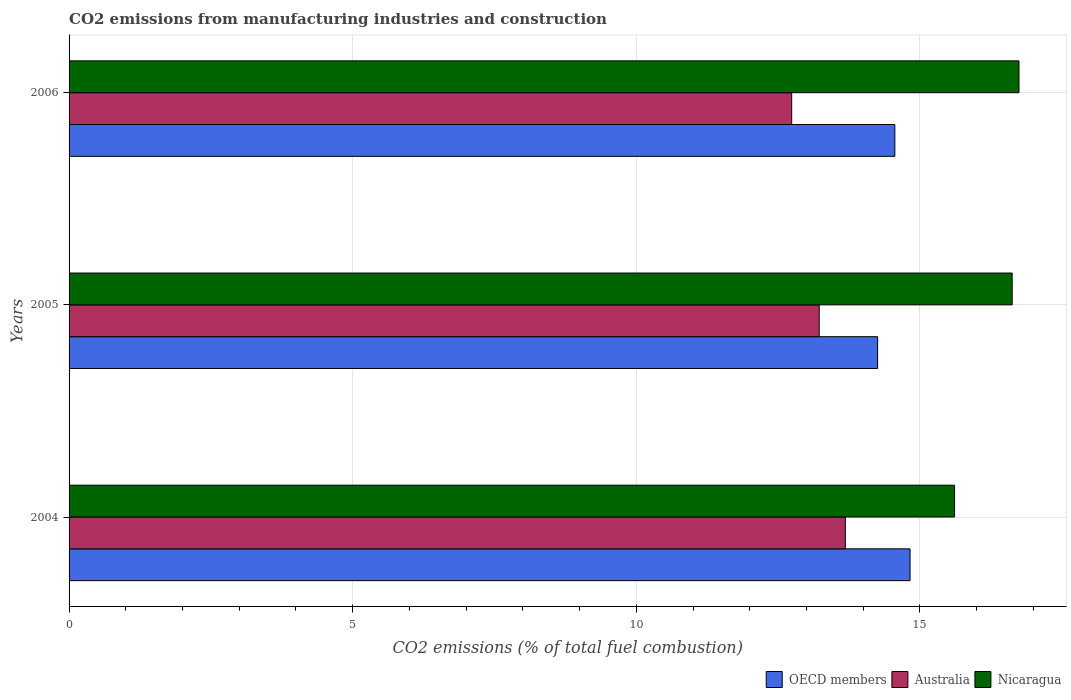How many different coloured bars are there?
Give a very brief answer. 3. Are the number of bars per tick equal to the number of legend labels?
Offer a very short reply. Yes. Are the number of bars on each tick of the Y-axis equal?
Give a very brief answer. Yes. How many bars are there on the 2nd tick from the top?
Your answer should be very brief. 3. How many bars are there on the 3rd tick from the bottom?
Your answer should be compact. 3. What is the label of the 1st group of bars from the top?
Your answer should be very brief. 2006. What is the amount of CO2 emitted in Australia in 2004?
Make the answer very short. 13.68. Across all years, what is the maximum amount of CO2 emitted in OECD members?
Give a very brief answer. 14.82. Across all years, what is the minimum amount of CO2 emitted in Nicaragua?
Keep it short and to the point. 15.61. In which year was the amount of CO2 emitted in Australia maximum?
Provide a short and direct response. 2004. What is the total amount of CO2 emitted in OECD members in the graph?
Ensure brevity in your answer.  43.63. What is the difference between the amount of CO2 emitted in OECD members in 2004 and that in 2006?
Give a very brief answer. 0.27. What is the difference between the amount of CO2 emitted in Australia in 2006 and the amount of CO2 emitted in Nicaragua in 2005?
Ensure brevity in your answer.  -3.89. What is the average amount of CO2 emitted in Nicaragua per year?
Give a very brief answer. 16.33. In the year 2004, what is the difference between the amount of CO2 emitted in Nicaragua and amount of CO2 emitted in OECD members?
Keep it short and to the point. 0.78. What is the ratio of the amount of CO2 emitted in Australia in 2005 to that in 2006?
Your response must be concise. 1.04. Is the amount of CO2 emitted in OECD members in 2004 less than that in 2005?
Your answer should be compact. No. Is the difference between the amount of CO2 emitted in Nicaragua in 2004 and 2006 greater than the difference between the amount of CO2 emitted in OECD members in 2004 and 2006?
Your response must be concise. No. What is the difference between the highest and the second highest amount of CO2 emitted in Nicaragua?
Ensure brevity in your answer.  0.12. What is the difference between the highest and the lowest amount of CO2 emitted in OECD members?
Provide a short and direct response. 0.57. In how many years, is the amount of CO2 emitted in OECD members greater than the average amount of CO2 emitted in OECD members taken over all years?
Your response must be concise. 2. What does the 2nd bar from the bottom in 2005 represents?
Your answer should be very brief. Australia. How many bars are there?
Your response must be concise. 9. Are all the bars in the graph horizontal?
Give a very brief answer. Yes. What is the difference between two consecutive major ticks on the X-axis?
Ensure brevity in your answer.  5. Are the values on the major ticks of X-axis written in scientific E-notation?
Offer a terse response. No. Does the graph contain any zero values?
Keep it short and to the point. No. Does the graph contain grids?
Your response must be concise. Yes. How are the legend labels stacked?
Your response must be concise. Horizontal. What is the title of the graph?
Offer a very short reply. CO2 emissions from manufacturing industries and construction. What is the label or title of the X-axis?
Your answer should be compact. CO2 emissions (% of total fuel combustion). What is the CO2 emissions (% of total fuel combustion) of OECD members in 2004?
Make the answer very short. 14.82. What is the CO2 emissions (% of total fuel combustion) in Australia in 2004?
Offer a terse response. 13.68. What is the CO2 emissions (% of total fuel combustion) in Nicaragua in 2004?
Provide a short and direct response. 15.61. What is the CO2 emissions (% of total fuel combustion) in OECD members in 2005?
Provide a succinct answer. 14.25. What is the CO2 emissions (% of total fuel combustion) in Australia in 2005?
Make the answer very short. 13.22. What is the CO2 emissions (% of total fuel combustion) in Nicaragua in 2005?
Your answer should be very brief. 16.63. What is the CO2 emissions (% of total fuel combustion) of OECD members in 2006?
Your response must be concise. 14.56. What is the CO2 emissions (% of total fuel combustion) of Australia in 2006?
Provide a succinct answer. 12.74. What is the CO2 emissions (% of total fuel combustion) of Nicaragua in 2006?
Ensure brevity in your answer.  16.75. Across all years, what is the maximum CO2 emissions (% of total fuel combustion) of OECD members?
Give a very brief answer. 14.82. Across all years, what is the maximum CO2 emissions (% of total fuel combustion) in Australia?
Offer a terse response. 13.68. Across all years, what is the maximum CO2 emissions (% of total fuel combustion) in Nicaragua?
Your answer should be very brief. 16.75. Across all years, what is the minimum CO2 emissions (% of total fuel combustion) in OECD members?
Provide a succinct answer. 14.25. Across all years, what is the minimum CO2 emissions (% of total fuel combustion) of Australia?
Offer a terse response. 12.74. Across all years, what is the minimum CO2 emissions (% of total fuel combustion) of Nicaragua?
Provide a succinct answer. 15.61. What is the total CO2 emissions (% of total fuel combustion) of OECD members in the graph?
Provide a short and direct response. 43.63. What is the total CO2 emissions (% of total fuel combustion) in Australia in the graph?
Your answer should be very brief. 39.65. What is the total CO2 emissions (% of total fuel combustion) of Nicaragua in the graph?
Provide a short and direct response. 48.98. What is the difference between the CO2 emissions (% of total fuel combustion) in OECD members in 2004 and that in 2005?
Provide a short and direct response. 0.57. What is the difference between the CO2 emissions (% of total fuel combustion) of Australia in 2004 and that in 2005?
Your answer should be compact. 0.46. What is the difference between the CO2 emissions (% of total fuel combustion) in Nicaragua in 2004 and that in 2005?
Your answer should be very brief. -1.02. What is the difference between the CO2 emissions (% of total fuel combustion) of OECD members in 2004 and that in 2006?
Your response must be concise. 0.27. What is the difference between the CO2 emissions (% of total fuel combustion) of Australia in 2004 and that in 2006?
Your response must be concise. 0.95. What is the difference between the CO2 emissions (% of total fuel combustion) in Nicaragua in 2004 and that in 2006?
Keep it short and to the point. -1.14. What is the difference between the CO2 emissions (% of total fuel combustion) of OECD members in 2005 and that in 2006?
Your answer should be very brief. -0.3. What is the difference between the CO2 emissions (% of total fuel combustion) of Australia in 2005 and that in 2006?
Ensure brevity in your answer.  0.49. What is the difference between the CO2 emissions (% of total fuel combustion) of Nicaragua in 2005 and that in 2006?
Provide a succinct answer. -0.12. What is the difference between the CO2 emissions (% of total fuel combustion) in OECD members in 2004 and the CO2 emissions (% of total fuel combustion) in Australia in 2005?
Keep it short and to the point. 1.6. What is the difference between the CO2 emissions (% of total fuel combustion) of OECD members in 2004 and the CO2 emissions (% of total fuel combustion) of Nicaragua in 2005?
Provide a succinct answer. -1.8. What is the difference between the CO2 emissions (% of total fuel combustion) in Australia in 2004 and the CO2 emissions (% of total fuel combustion) in Nicaragua in 2005?
Your answer should be very brief. -2.94. What is the difference between the CO2 emissions (% of total fuel combustion) in OECD members in 2004 and the CO2 emissions (% of total fuel combustion) in Australia in 2006?
Provide a short and direct response. 2.09. What is the difference between the CO2 emissions (% of total fuel combustion) of OECD members in 2004 and the CO2 emissions (% of total fuel combustion) of Nicaragua in 2006?
Ensure brevity in your answer.  -1.92. What is the difference between the CO2 emissions (% of total fuel combustion) of Australia in 2004 and the CO2 emissions (% of total fuel combustion) of Nicaragua in 2006?
Keep it short and to the point. -3.06. What is the difference between the CO2 emissions (% of total fuel combustion) in OECD members in 2005 and the CO2 emissions (% of total fuel combustion) in Australia in 2006?
Offer a very short reply. 1.51. What is the difference between the CO2 emissions (% of total fuel combustion) of OECD members in 2005 and the CO2 emissions (% of total fuel combustion) of Nicaragua in 2006?
Keep it short and to the point. -2.49. What is the difference between the CO2 emissions (% of total fuel combustion) in Australia in 2005 and the CO2 emissions (% of total fuel combustion) in Nicaragua in 2006?
Your answer should be very brief. -3.52. What is the average CO2 emissions (% of total fuel combustion) of OECD members per year?
Give a very brief answer. 14.54. What is the average CO2 emissions (% of total fuel combustion) in Australia per year?
Your answer should be very brief. 13.22. What is the average CO2 emissions (% of total fuel combustion) in Nicaragua per year?
Give a very brief answer. 16.33. In the year 2004, what is the difference between the CO2 emissions (% of total fuel combustion) in OECD members and CO2 emissions (% of total fuel combustion) in Australia?
Provide a succinct answer. 1.14. In the year 2004, what is the difference between the CO2 emissions (% of total fuel combustion) in OECD members and CO2 emissions (% of total fuel combustion) in Nicaragua?
Offer a terse response. -0.78. In the year 2004, what is the difference between the CO2 emissions (% of total fuel combustion) in Australia and CO2 emissions (% of total fuel combustion) in Nicaragua?
Offer a terse response. -1.93. In the year 2005, what is the difference between the CO2 emissions (% of total fuel combustion) in OECD members and CO2 emissions (% of total fuel combustion) in Australia?
Make the answer very short. 1.03. In the year 2005, what is the difference between the CO2 emissions (% of total fuel combustion) of OECD members and CO2 emissions (% of total fuel combustion) of Nicaragua?
Provide a succinct answer. -2.37. In the year 2005, what is the difference between the CO2 emissions (% of total fuel combustion) in Australia and CO2 emissions (% of total fuel combustion) in Nicaragua?
Give a very brief answer. -3.4. In the year 2006, what is the difference between the CO2 emissions (% of total fuel combustion) of OECD members and CO2 emissions (% of total fuel combustion) of Australia?
Provide a succinct answer. 1.82. In the year 2006, what is the difference between the CO2 emissions (% of total fuel combustion) in OECD members and CO2 emissions (% of total fuel combustion) in Nicaragua?
Give a very brief answer. -2.19. In the year 2006, what is the difference between the CO2 emissions (% of total fuel combustion) of Australia and CO2 emissions (% of total fuel combustion) of Nicaragua?
Your response must be concise. -4.01. What is the ratio of the CO2 emissions (% of total fuel combustion) of OECD members in 2004 to that in 2005?
Your answer should be very brief. 1.04. What is the ratio of the CO2 emissions (% of total fuel combustion) in Australia in 2004 to that in 2005?
Your response must be concise. 1.03. What is the ratio of the CO2 emissions (% of total fuel combustion) of Nicaragua in 2004 to that in 2005?
Offer a terse response. 0.94. What is the ratio of the CO2 emissions (% of total fuel combustion) in OECD members in 2004 to that in 2006?
Keep it short and to the point. 1.02. What is the ratio of the CO2 emissions (% of total fuel combustion) of Australia in 2004 to that in 2006?
Keep it short and to the point. 1.07. What is the ratio of the CO2 emissions (% of total fuel combustion) of Nicaragua in 2004 to that in 2006?
Keep it short and to the point. 0.93. What is the ratio of the CO2 emissions (% of total fuel combustion) in OECD members in 2005 to that in 2006?
Offer a very short reply. 0.98. What is the ratio of the CO2 emissions (% of total fuel combustion) of Australia in 2005 to that in 2006?
Your answer should be compact. 1.04. What is the difference between the highest and the second highest CO2 emissions (% of total fuel combustion) in OECD members?
Provide a succinct answer. 0.27. What is the difference between the highest and the second highest CO2 emissions (% of total fuel combustion) of Australia?
Keep it short and to the point. 0.46. What is the difference between the highest and the second highest CO2 emissions (% of total fuel combustion) in Nicaragua?
Ensure brevity in your answer.  0.12. What is the difference between the highest and the lowest CO2 emissions (% of total fuel combustion) of OECD members?
Offer a very short reply. 0.57. What is the difference between the highest and the lowest CO2 emissions (% of total fuel combustion) in Australia?
Offer a terse response. 0.95. What is the difference between the highest and the lowest CO2 emissions (% of total fuel combustion) of Nicaragua?
Give a very brief answer. 1.14. 